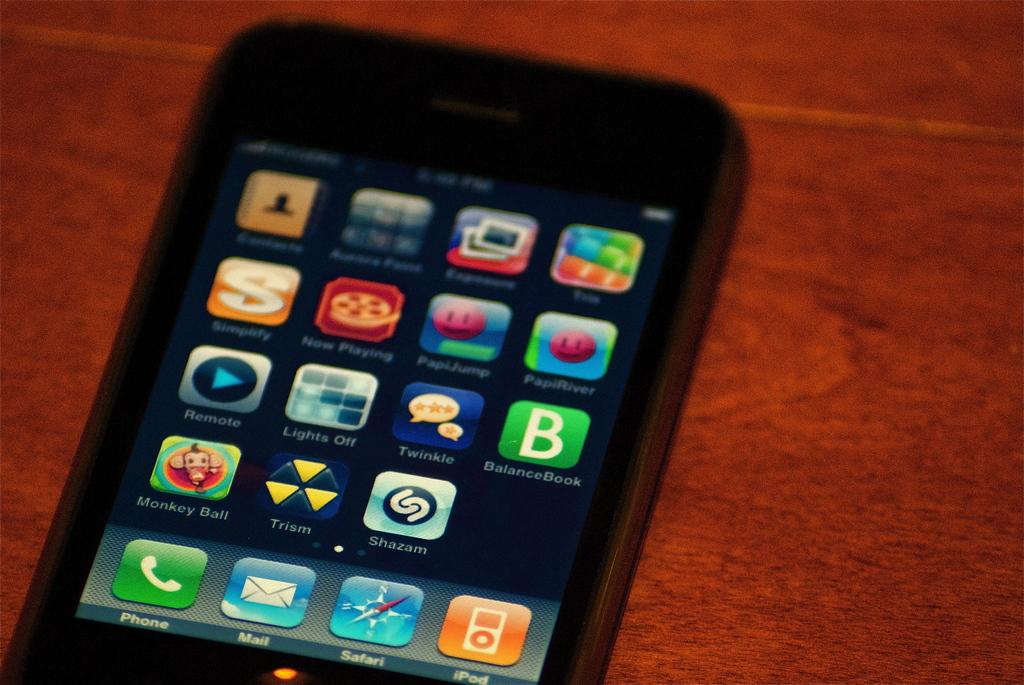What app is in the bottom left?
Make the answer very short. Phone. 